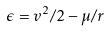Convert formula to latex. <formula><loc_0><loc_0><loc_500><loc_500>\epsilon = v ^ { 2 } / 2 - \mu / r</formula> 